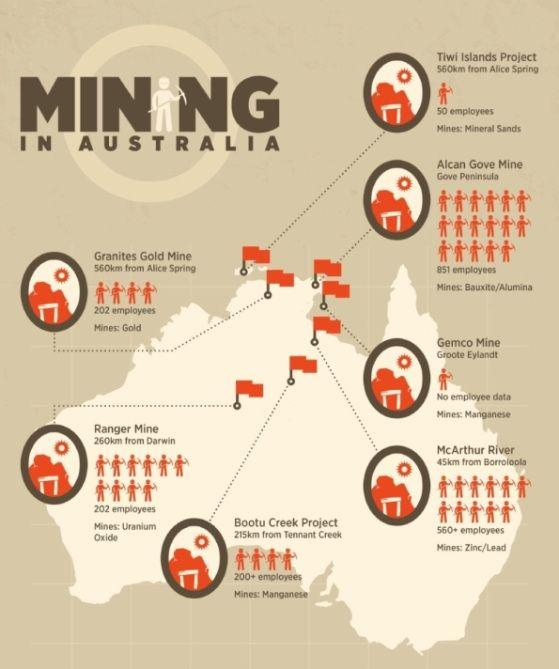Indicate a few pertinent items in this graphic. The map displays a total of 7 mining locations. The Bootu Creek Project employs over 200 employees. 